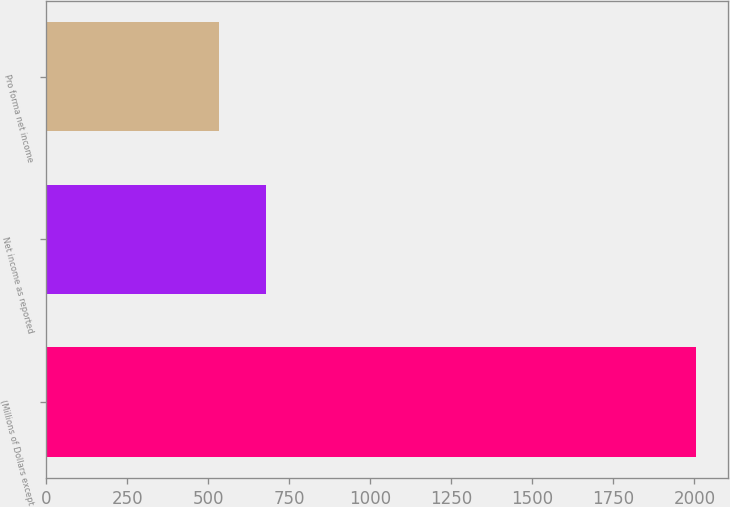<chart> <loc_0><loc_0><loc_500><loc_500><bar_chart><fcel>(Millions of Dollars except<fcel>Net income as reported<fcel>Pro forma net income<nl><fcel>2004<fcel>679.2<fcel>532<nl></chart> 